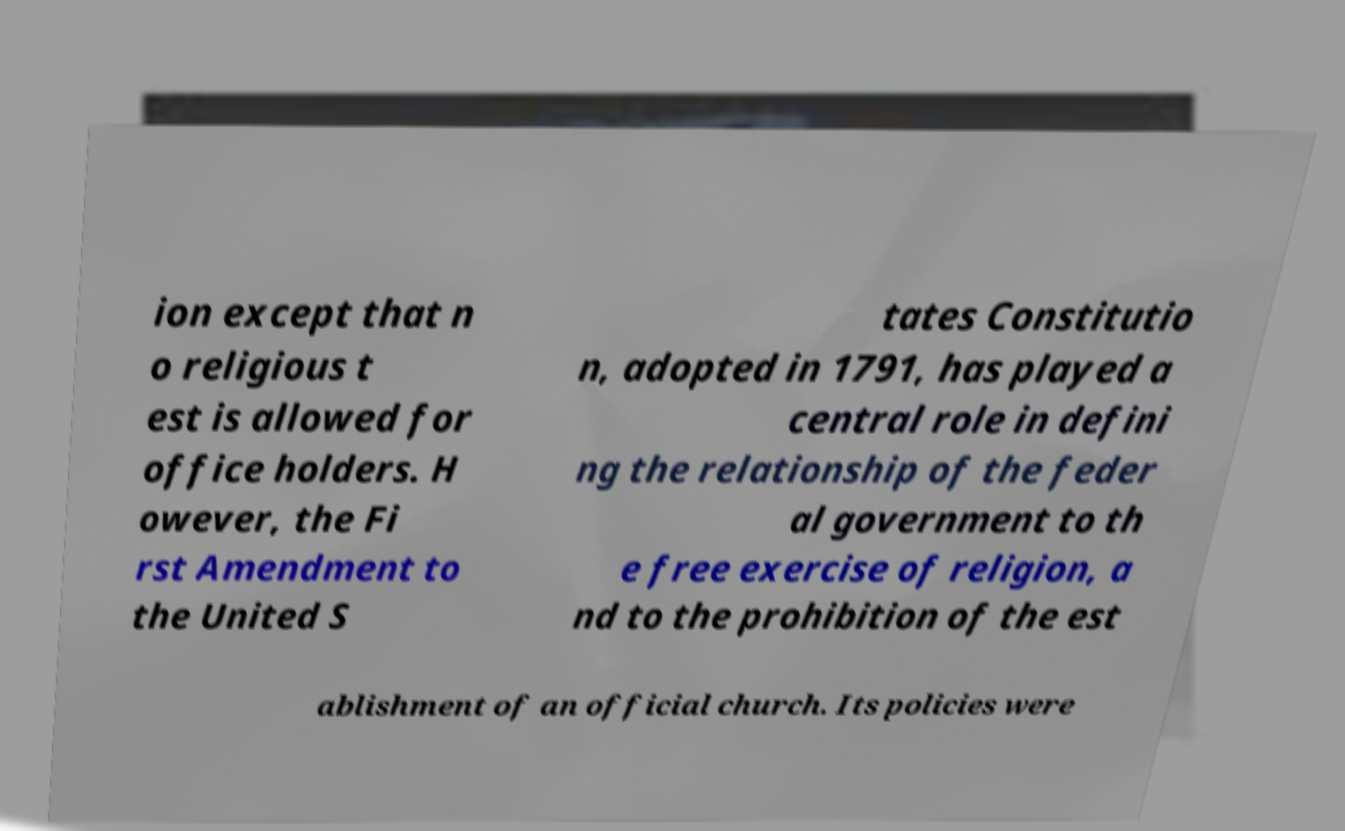What messages or text are displayed in this image? I need them in a readable, typed format. ion except that n o religious t est is allowed for office holders. H owever, the Fi rst Amendment to the United S tates Constitutio n, adopted in 1791, has played a central role in defini ng the relationship of the feder al government to th e free exercise of religion, a nd to the prohibition of the est ablishment of an official church. Its policies were 